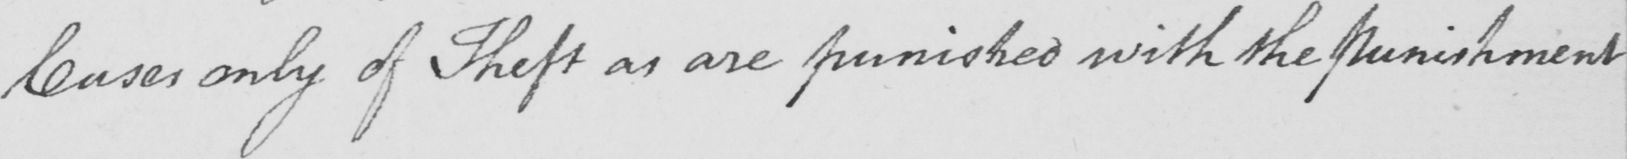Please transcribe the handwritten text in this image. Cases only of Theft as are punished with the Punishment 